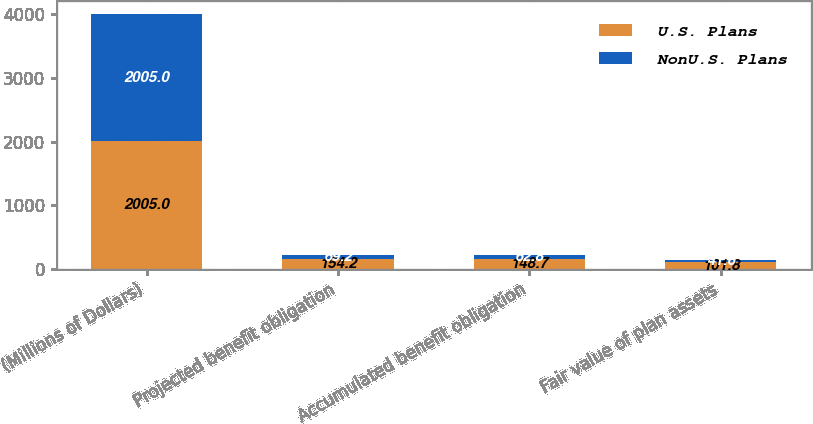<chart> <loc_0><loc_0><loc_500><loc_500><stacked_bar_chart><ecel><fcel>(Millions of Dollars)<fcel>Projected benefit obligation<fcel>Accumulated benefit obligation<fcel>Fair value of plan assets<nl><fcel>U.S. Plans<fcel>2005<fcel>154.2<fcel>148.7<fcel>101.8<nl><fcel>NonU.S. Plans<fcel>2005<fcel>69.2<fcel>62.8<fcel>41.6<nl></chart> 